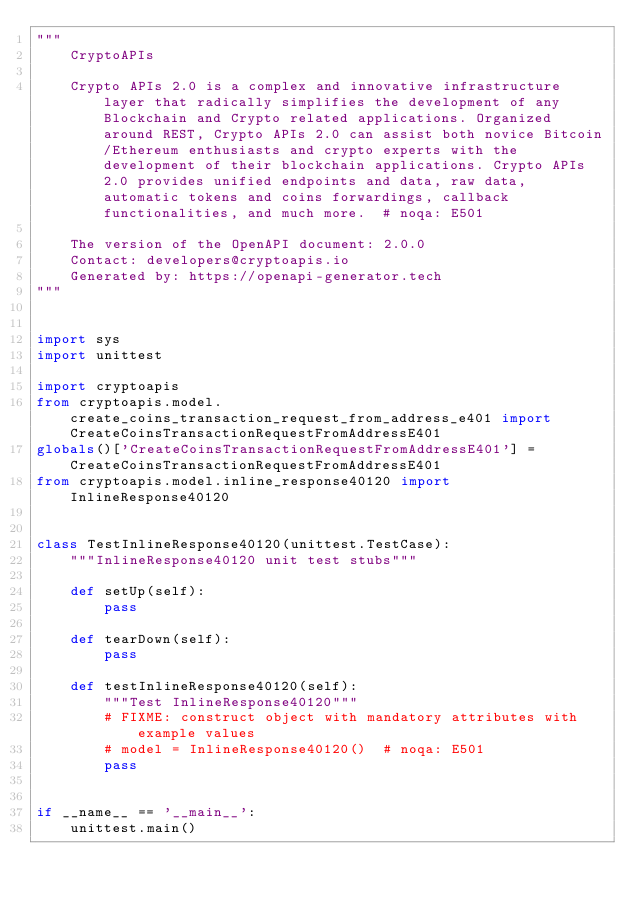Convert code to text. <code><loc_0><loc_0><loc_500><loc_500><_Python_>"""
    CryptoAPIs

    Crypto APIs 2.0 is a complex and innovative infrastructure layer that radically simplifies the development of any Blockchain and Crypto related applications. Organized around REST, Crypto APIs 2.0 can assist both novice Bitcoin/Ethereum enthusiasts and crypto experts with the development of their blockchain applications. Crypto APIs 2.0 provides unified endpoints and data, raw data, automatic tokens and coins forwardings, callback functionalities, and much more.  # noqa: E501

    The version of the OpenAPI document: 2.0.0
    Contact: developers@cryptoapis.io
    Generated by: https://openapi-generator.tech
"""


import sys
import unittest

import cryptoapis
from cryptoapis.model.create_coins_transaction_request_from_address_e401 import CreateCoinsTransactionRequestFromAddressE401
globals()['CreateCoinsTransactionRequestFromAddressE401'] = CreateCoinsTransactionRequestFromAddressE401
from cryptoapis.model.inline_response40120 import InlineResponse40120


class TestInlineResponse40120(unittest.TestCase):
    """InlineResponse40120 unit test stubs"""

    def setUp(self):
        pass

    def tearDown(self):
        pass

    def testInlineResponse40120(self):
        """Test InlineResponse40120"""
        # FIXME: construct object with mandatory attributes with example values
        # model = InlineResponse40120()  # noqa: E501
        pass


if __name__ == '__main__':
    unittest.main()
</code> 